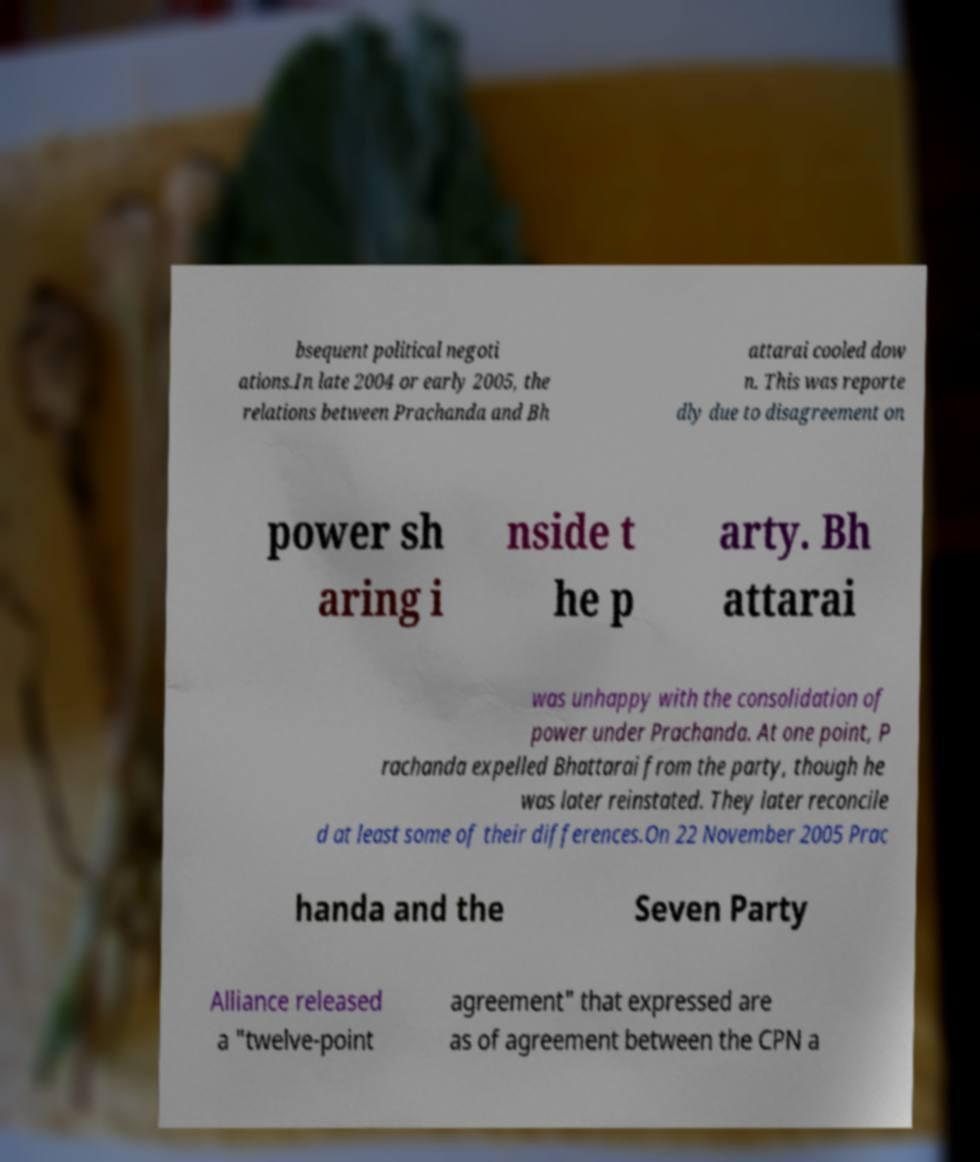Could you extract and type out the text from this image? bsequent political negoti ations.In late 2004 or early 2005, the relations between Prachanda and Bh attarai cooled dow n. This was reporte dly due to disagreement on power sh aring i nside t he p arty. Bh attarai was unhappy with the consolidation of power under Prachanda. At one point, P rachanda expelled Bhattarai from the party, though he was later reinstated. They later reconcile d at least some of their differences.On 22 November 2005 Prac handa and the Seven Party Alliance released a "twelve-point agreement" that expressed are as of agreement between the CPN a 